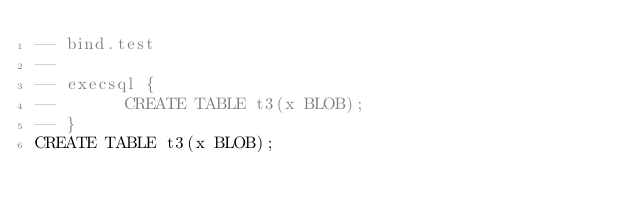<code> <loc_0><loc_0><loc_500><loc_500><_SQL_>-- bind.test
-- 
-- execsql {
--       CREATE TABLE t3(x BLOB);
-- }
CREATE TABLE t3(x BLOB);</code> 